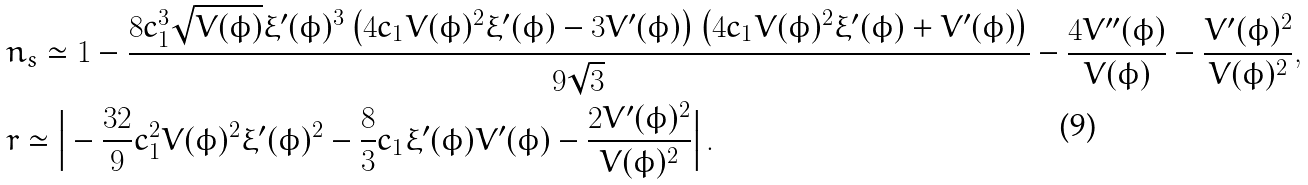Convert formula to latex. <formula><loc_0><loc_0><loc_500><loc_500>& n _ { s } \simeq 1 - \frac { 8 c _ { 1 } ^ { 3 } \sqrt { V ( \phi ) } \xi ^ { \prime } ( \phi ) ^ { 3 } \left ( 4 c _ { 1 } V ( \phi ) ^ { 2 } \xi ^ { \prime } ( \phi ) - 3 V ^ { \prime } ( \phi ) \right ) \left ( 4 c _ { 1 } V ( \phi ) ^ { 2 } \xi ^ { \prime } ( \phi ) + V ^ { \prime } ( \phi ) \right ) } { 9 \sqrt { 3 } } - \frac { 4 V ^ { \prime \prime } ( \phi ) } { V ( \phi ) } - \frac { V ^ { \prime } ( \phi ) ^ { 2 } } { V ( \phi ) ^ { 2 } } , \\ & r \simeq \Big { | } - \frac { 3 2 } { 9 } c _ { 1 } ^ { 2 } V ( \phi ) ^ { 2 } \xi ^ { \prime } ( \phi ) ^ { 2 } - \frac { 8 } { 3 } c _ { 1 } \xi ^ { \prime } ( \phi ) V ^ { \prime } ( \phi ) - \frac { 2 V ^ { \prime } ( \phi ) ^ { 2 } } { V ( \phi ) ^ { 2 } } \Big { | } \, .</formula> 